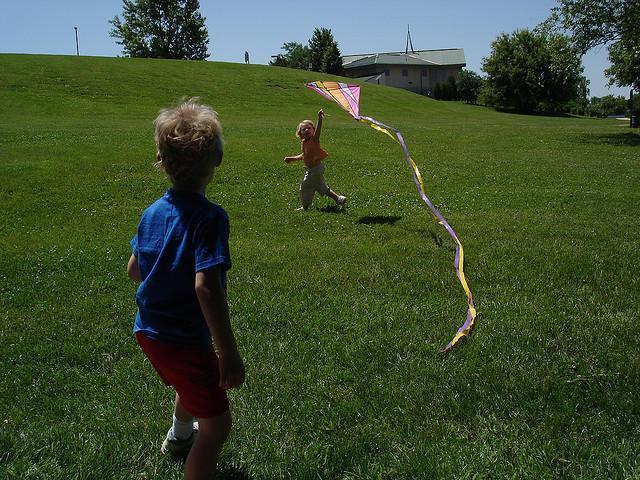How many cows are in the picture?
Give a very brief answer. 0. How many kids?
Give a very brief answer. 2. How many adults are in the picture?
Give a very brief answer. 0. How many people are there?
Give a very brief answer. 2. 